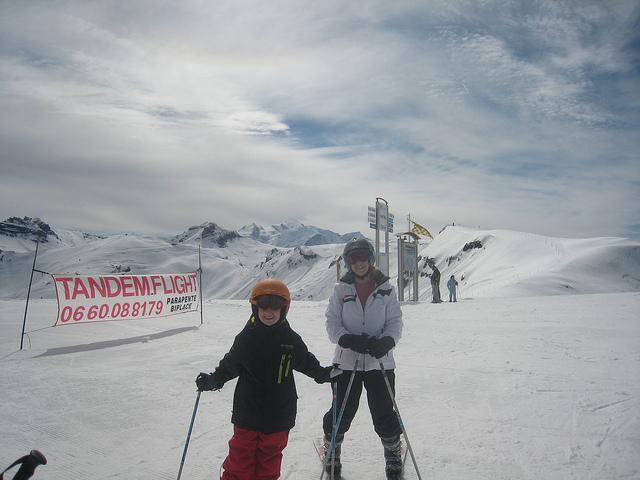What type of activity is this? Please explain your reasoning. winter. There is snow on the ground and this only occurs in this particular season. 